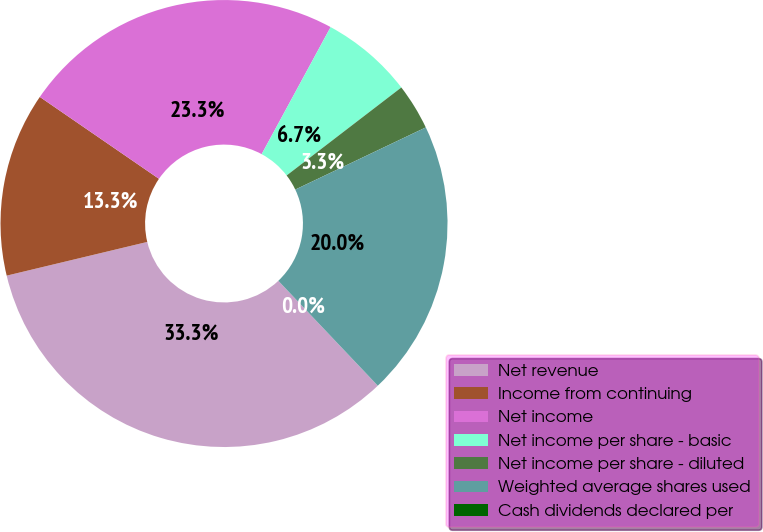<chart> <loc_0><loc_0><loc_500><loc_500><pie_chart><fcel>Net revenue<fcel>Income from continuing<fcel>Net income<fcel>Net income per share - basic<fcel>Net income per share - diluted<fcel>Weighted average shares used<fcel>Cash dividends declared per<nl><fcel>33.33%<fcel>13.33%<fcel>23.33%<fcel>6.67%<fcel>3.34%<fcel>20.0%<fcel>0.0%<nl></chart> 